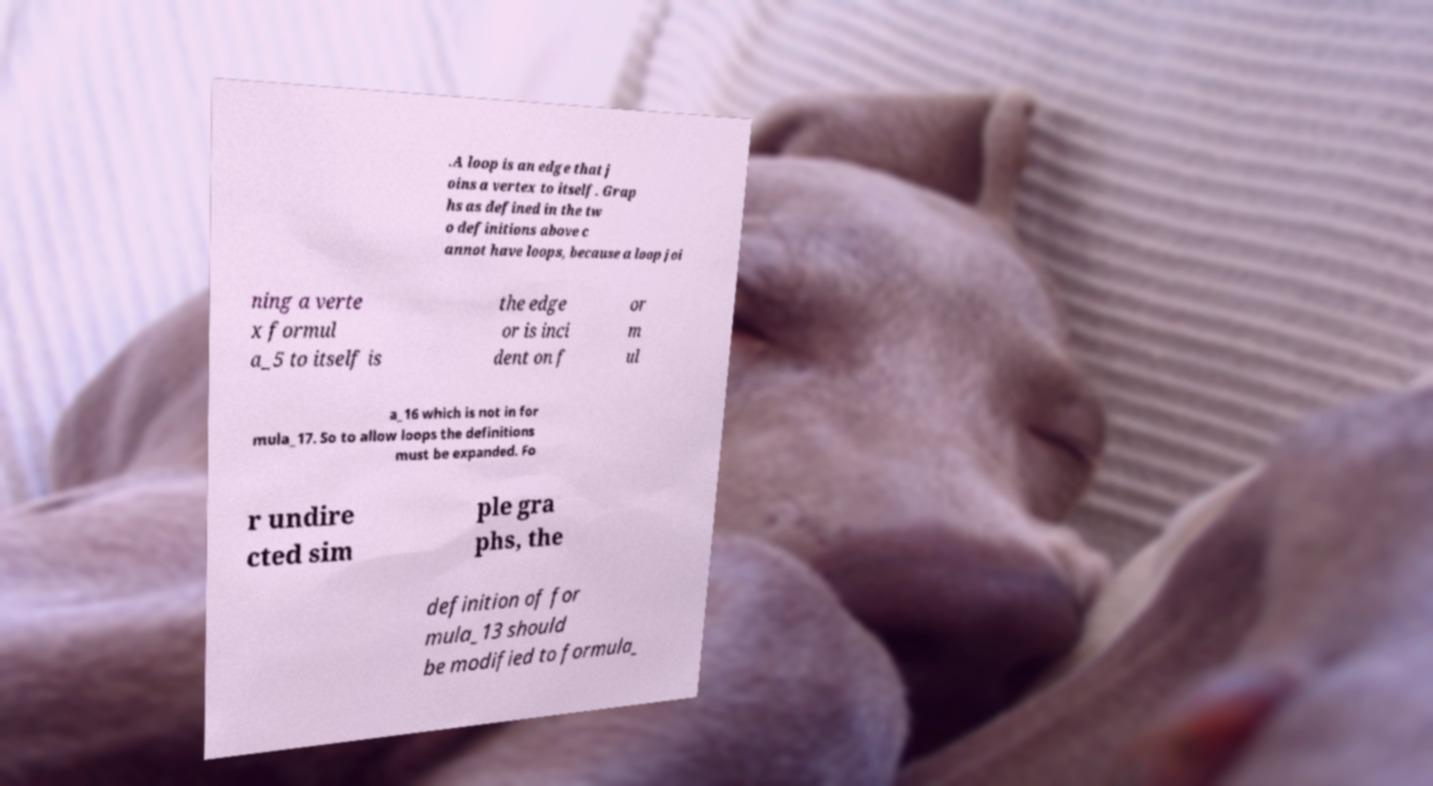Could you extract and type out the text from this image? .A loop is an edge that j oins a vertex to itself. Grap hs as defined in the tw o definitions above c annot have loops, because a loop joi ning a verte x formul a_5 to itself is the edge or is inci dent on f or m ul a_16 which is not in for mula_17. So to allow loops the definitions must be expanded. Fo r undire cted sim ple gra phs, the definition of for mula_13 should be modified to formula_ 